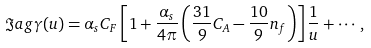<formula> <loc_0><loc_0><loc_500><loc_500>\Im a g \gamma ( u ) = \alpha _ { s } C _ { F } \left [ 1 + \frac { \alpha _ { s } } { 4 \pi } \left ( \frac { 3 1 } { 9 } C _ { A } - \frac { 1 0 } { 9 } n _ { f } \right ) \right ] \frac { 1 } { u } + \cdots ,</formula> 